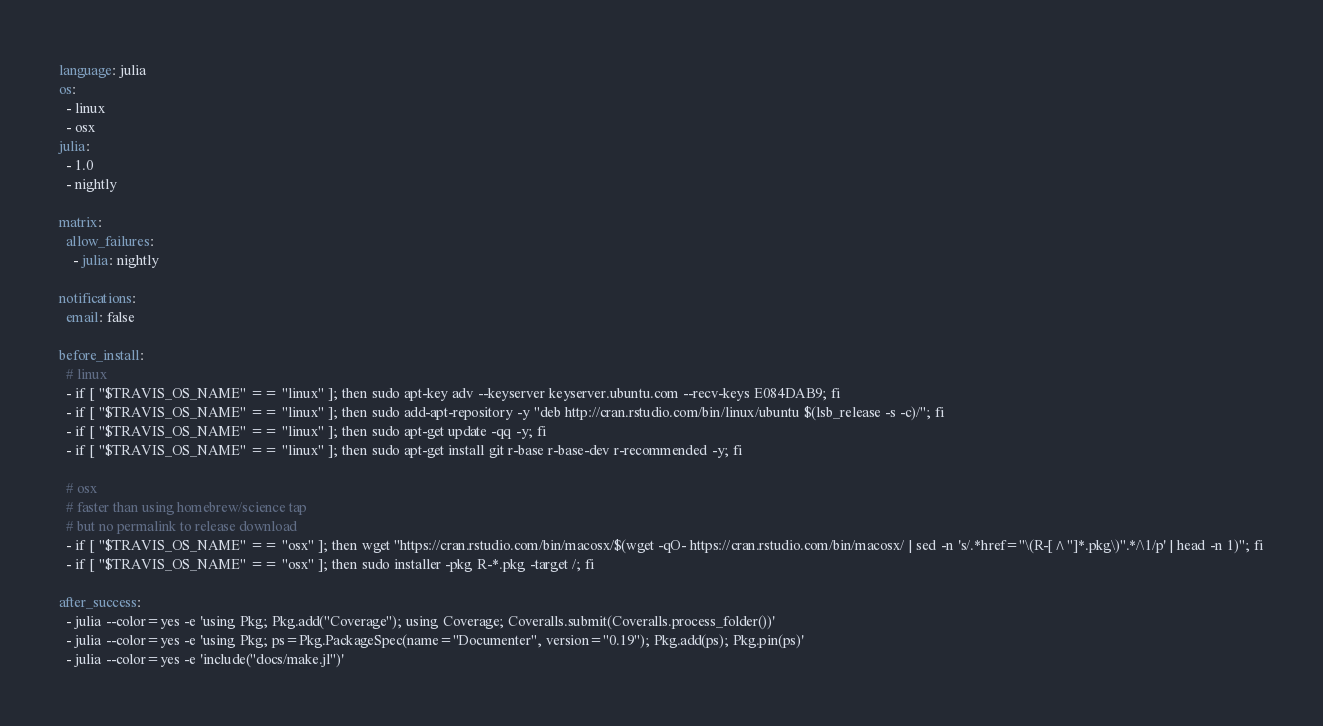<code> <loc_0><loc_0><loc_500><loc_500><_YAML_>language: julia
os:
  - linux
  - osx
julia:
  - 1.0
  - nightly

matrix:
  allow_failures:
    - julia: nightly

notifications:
  email: false

before_install:
  # linux
  - if [ "$TRAVIS_OS_NAME" == "linux" ]; then sudo apt-key adv --keyserver keyserver.ubuntu.com --recv-keys E084DAB9; fi
  - if [ "$TRAVIS_OS_NAME" == "linux" ]; then sudo add-apt-repository -y "deb http://cran.rstudio.com/bin/linux/ubuntu $(lsb_release -s -c)/"; fi
  - if [ "$TRAVIS_OS_NAME" == "linux" ]; then sudo apt-get update -qq -y; fi
  - if [ "$TRAVIS_OS_NAME" == "linux" ]; then sudo apt-get install git r-base r-base-dev r-recommended -y; fi

  # osx
  # faster than using homebrew/science tap
  # but no permalink to release download
  - if [ "$TRAVIS_OS_NAME" == "osx" ]; then wget "https://cran.rstudio.com/bin/macosx/$(wget -qO- https://cran.rstudio.com/bin/macosx/ | sed -n 's/.*href="\(R-[^"]*.pkg\)".*/\1/p' | head -n 1)"; fi
  - if [ "$TRAVIS_OS_NAME" == "osx" ]; then sudo installer -pkg R-*.pkg -target /; fi

after_success:
  - julia --color=yes -e 'using Pkg; Pkg.add("Coverage"); using Coverage; Coveralls.submit(Coveralls.process_folder())'
  - julia --color=yes -e 'using Pkg; ps=Pkg.PackageSpec(name="Documenter", version="0.19"); Pkg.add(ps); Pkg.pin(ps)'
  - julia --color=yes -e 'include("docs/make.jl")'
</code> 